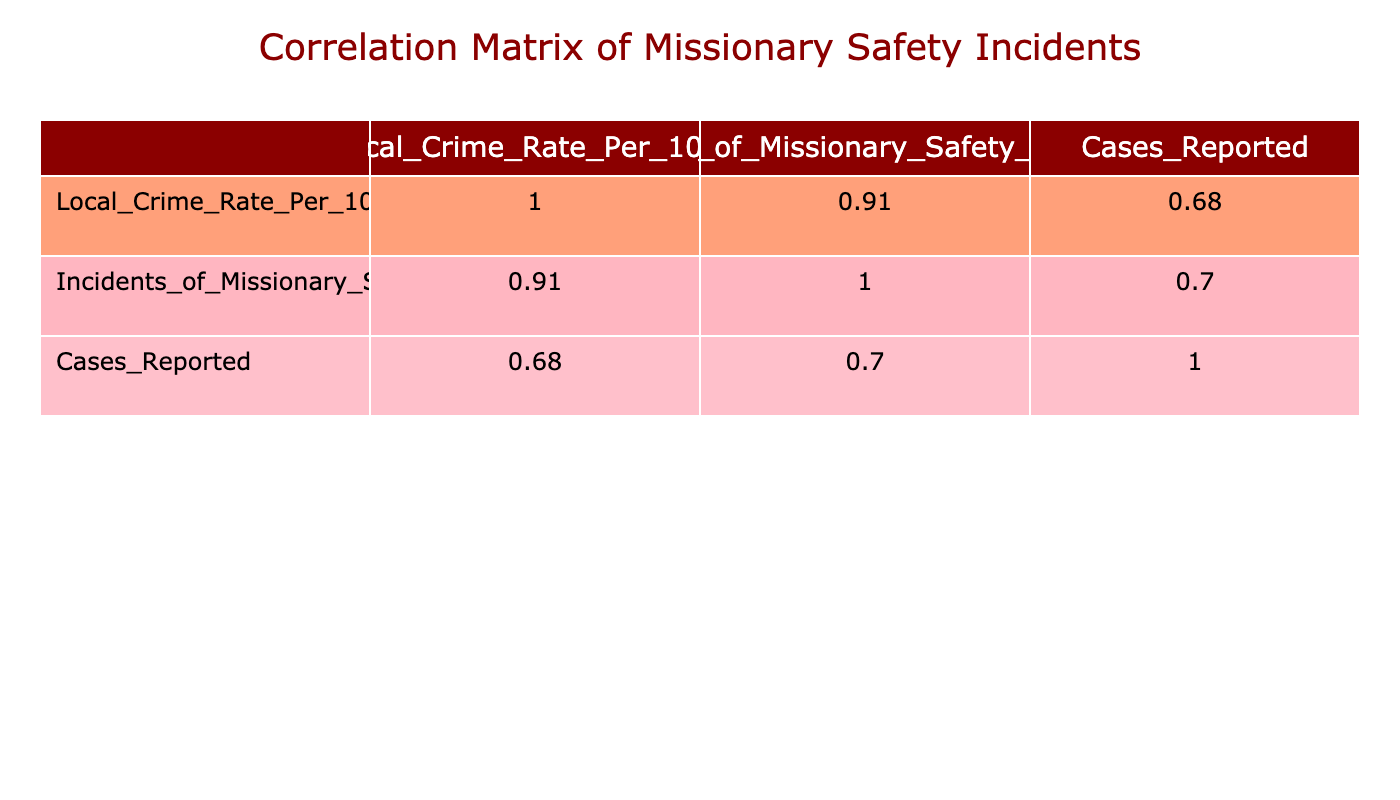What is the local crime rate per 1000 in Brazil for the year 2023? From the table, the row for Brazil in 2023 specifically lists the local crime rate as 30.
Answer: 30 Which country had the highest reported incidents of missionary safety concerns? In the table, the highest value under incidents of missionary safety concerns is 35, which corresponds to South Africa in 2023.
Answer: South Africa What is the average local crime rate across the years for Kenya? To find the average, sum the local crime rates for Kenya in 2022 (40) and 2023 (35): 40 + 35 = 75. Then divide by the number of years (2): 75/2 = 37.5.
Answer: 37.5 Did India report any abductions as incidents of missionary safety concerns? Looking at the data, India has only listed assault and theft as types of incidents, with no mention of abduction, making this statement false.
Answer: No How many total cases reported were there across all incidents of missionary safety concerns in Honduras? For Honduras, add the cases reported for 2022 (15 for assault) and 2023 (5 for abduction): 15 + 5 = 20.
Answer: 20 What is the correlation between the local crime rate and incidents of missionary safety concerns? By examining the correlation table, you can see the value in the row for Local Crime Rate and the column for Incidents of Missionary Safety Concerns, which shows a positive correlation, indicating that as crime rates increase, safety incidents also tend to rise.
Answer: Positive correlation Is there any year in which India reported more incidents of missionary safety concerns than Brazil? Checking the incidents reported, in 2023 Brazil reported 18 incidents while India only reported 6, so it is clear that during both years, Brazil had more incidents.
Answer: No What is the change in cases reported for South Africa from 2022 to 2023? For South Africa, subtract the cases reported in 2022 (20) from those in 2023 (12): 12 - 20 results in -8, indicating a decrease in reported cases.
Answer: Decrease of 8 cases 